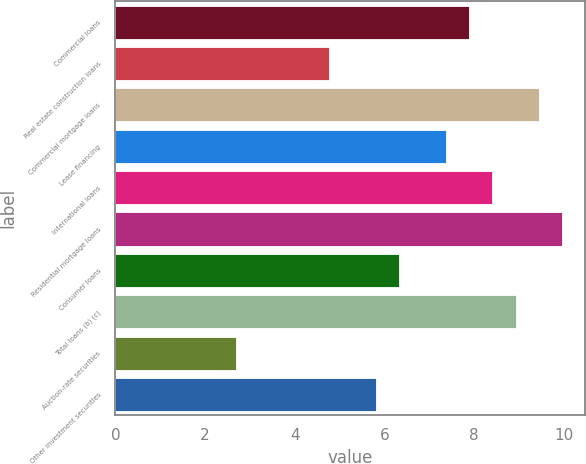Convert chart to OTSL. <chart><loc_0><loc_0><loc_500><loc_500><bar_chart><fcel>Commercial loans<fcel>Real estate construction loans<fcel>Commercial mortgage loans<fcel>Lease financing<fcel>International loans<fcel>Residential mortgage loans<fcel>Consumer loans<fcel>Total loans (b) (c)<fcel>Auction-rate securities<fcel>Other investment securities<nl><fcel>7.88<fcel>4.76<fcel>9.44<fcel>7.36<fcel>8.4<fcel>9.96<fcel>6.32<fcel>8.92<fcel>2.68<fcel>5.8<nl></chart> 